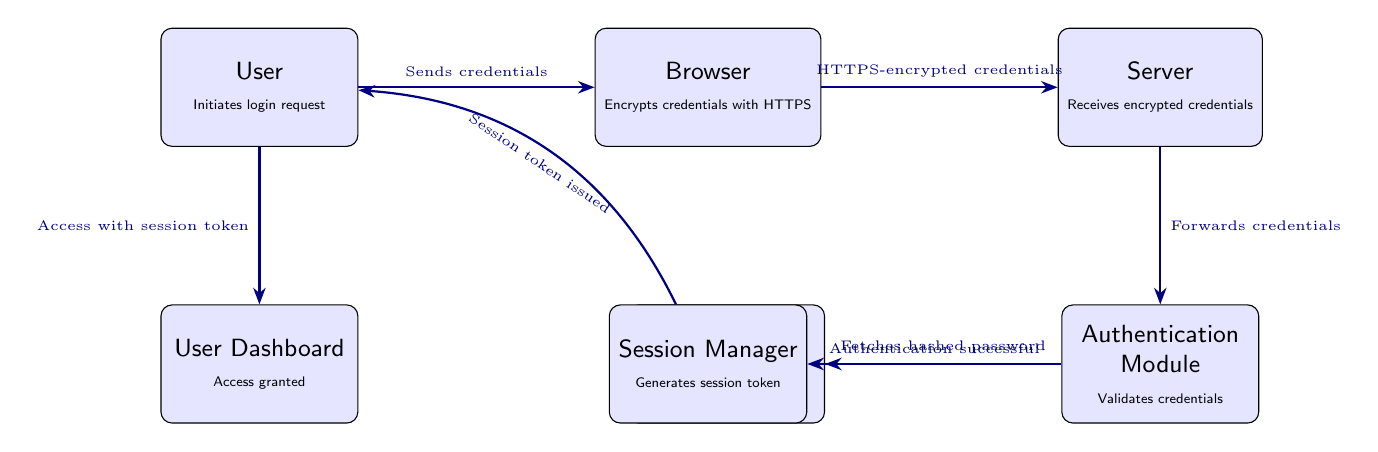What initiates the process in the diagram? The process begins when the user initiates a login request, as indicated by the first node in the diagram.
Answer: User How many nodes are present in the diagram? Counting the nodes shown in the diagram results in a total of seven distinct nodes.
Answer: 7 What type of connection exists between the browser and the server? The diagram specifies that the connection between the browser and server features HTTPS-encrypted credentials, which protects the data being transferred.
Answer: HTTPS-encrypted credentials What is the role of the Authentication Module in the flow? The Authentication Module's role is to validate credentials. This is noted in the connection from the server to this module in the diagram.
Answer: Validates credentials What does the Session Manager generate after successful authentication? After successful authentication, the Session Manager issues a session token, indicated by the arrow flowing out from the Authentication Module.
Answer: Session token What does the user access after receiving the session token? After obtaining the session token, the user gains access to their dashboard according to the final flow in the diagram.
Answer: User Dashboard Which node fetches the hashed password? The Authentication Module is responsible for fetching the hashed password from the database, as shown by the arrow pointing to the database from the Authentication Module.
Answer: Authentication Module How does the user send their credentials initially? The user's credentials are sent through a login request, which is clearly stated in the relationship labeled between the user node and the browser node.
Answer: Sends credentials What is the action performed by the Database node? The action performed by the Database node is to store hashed passwords, which is explicitly described in the information within the node.
Answer: Stores hashed passwords 